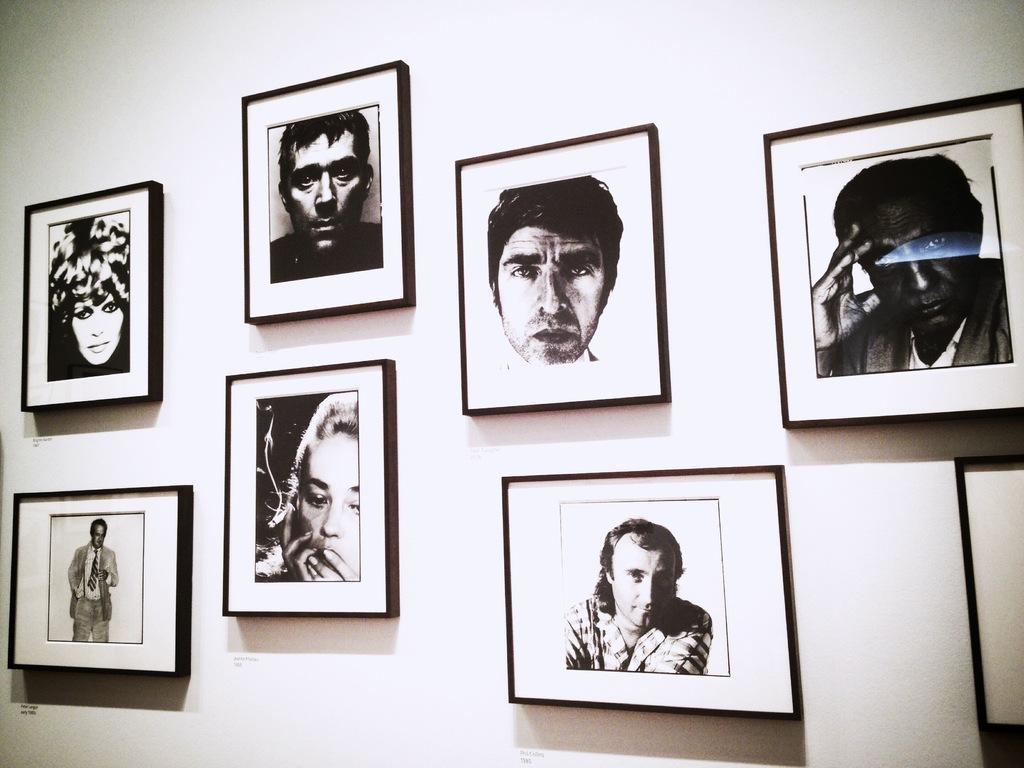Describe this image in one or two sentences. In this picture I can observe some photo frames on the wall. There are men and women in these frames. This is a black and white image. 